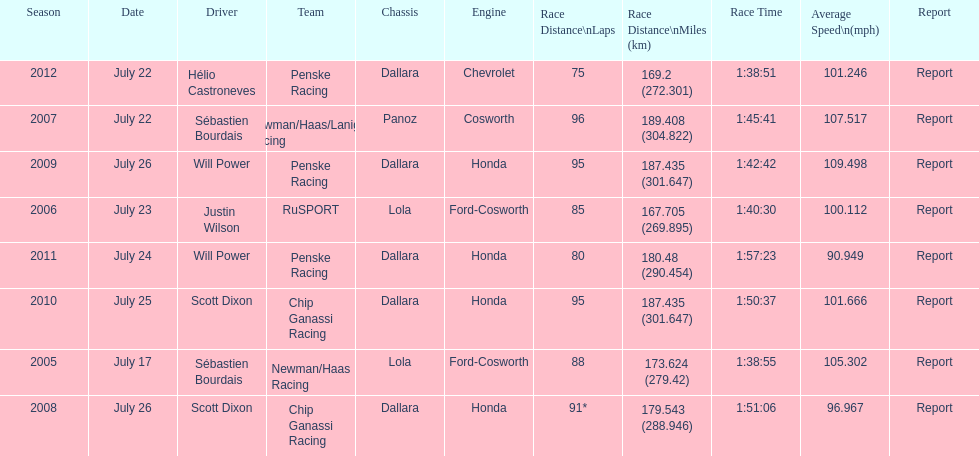How many flags other than france (the first flag) are represented? 3. 